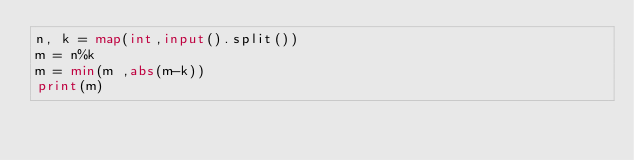Convert code to text. <code><loc_0><loc_0><loc_500><loc_500><_Python_>n, k = map(int,input().split())
m = n%k
m = min(m ,abs(m-k))
print(m)</code> 